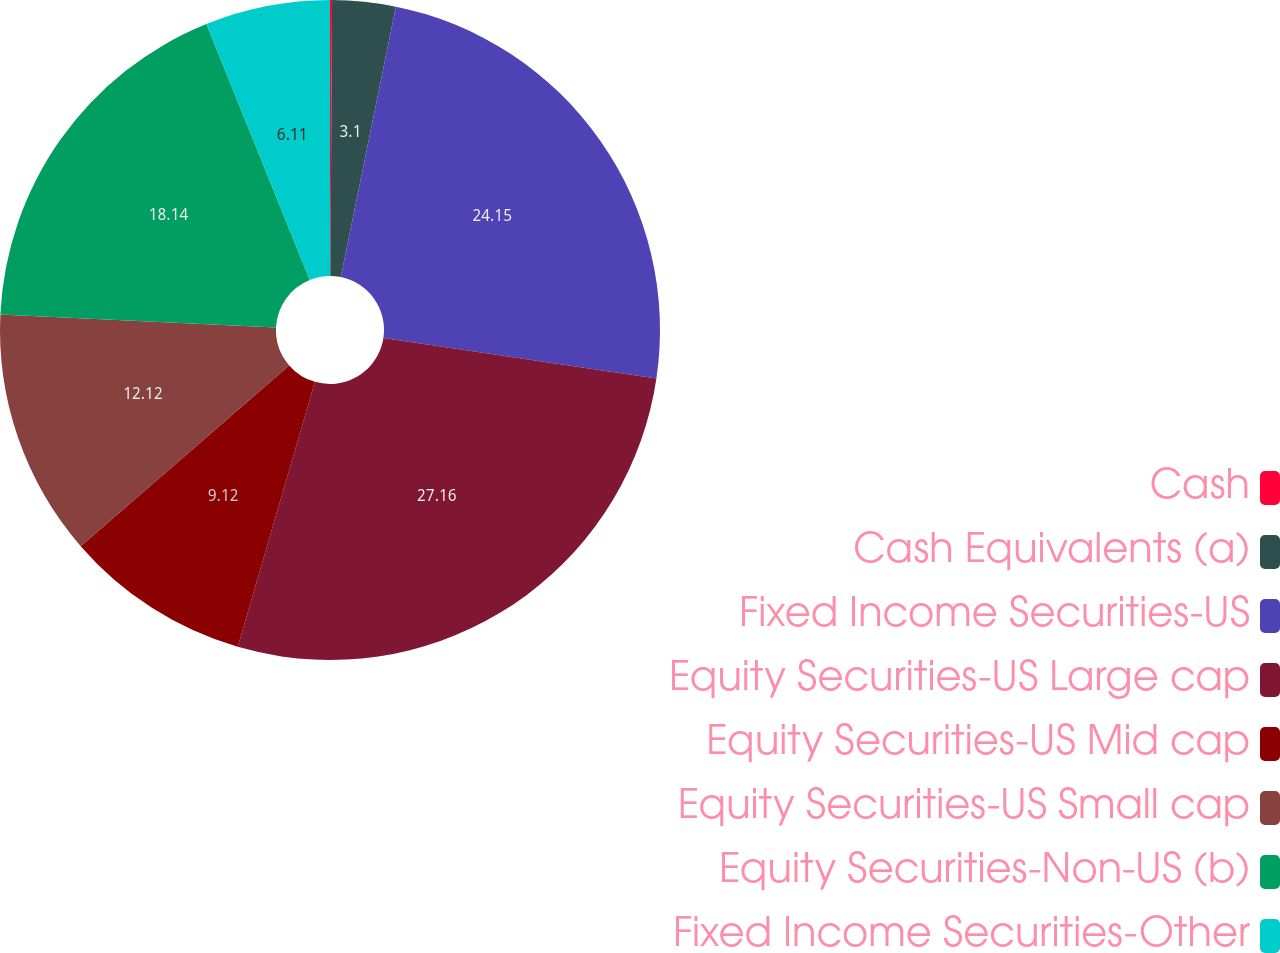<chart> <loc_0><loc_0><loc_500><loc_500><pie_chart><fcel>Cash<fcel>Cash Equivalents (a)<fcel>Fixed Income Securities-US<fcel>Equity Securities-US Large cap<fcel>Equity Securities-US Mid cap<fcel>Equity Securities-US Small cap<fcel>Equity Securities-Non-US (b)<fcel>Fixed Income Securities-Other<nl><fcel>0.1%<fcel>3.1%<fcel>24.15%<fcel>27.16%<fcel>9.12%<fcel>12.12%<fcel>18.14%<fcel>6.11%<nl></chart> 